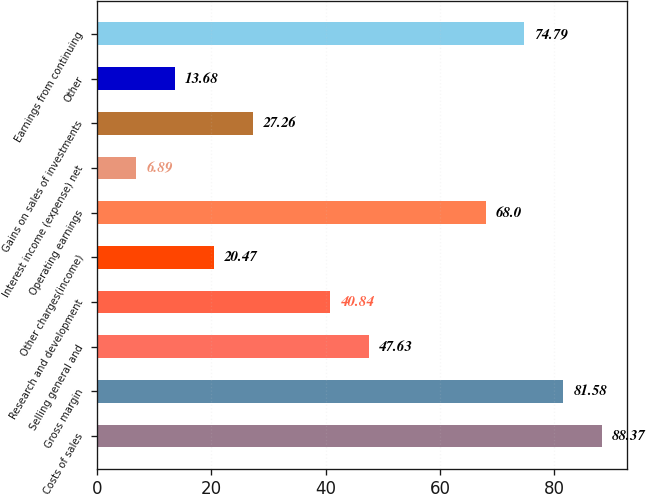Convert chart to OTSL. <chart><loc_0><loc_0><loc_500><loc_500><bar_chart><fcel>Costs of sales<fcel>Gross margin<fcel>Selling general and<fcel>Research and development<fcel>Other charges(income)<fcel>Operating earnings<fcel>Interest income (expense) net<fcel>Gains on sales of investments<fcel>Other<fcel>Earnings from continuing<nl><fcel>88.37<fcel>81.58<fcel>47.63<fcel>40.84<fcel>20.47<fcel>68<fcel>6.89<fcel>27.26<fcel>13.68<fcel>74.79<nl></chart> 